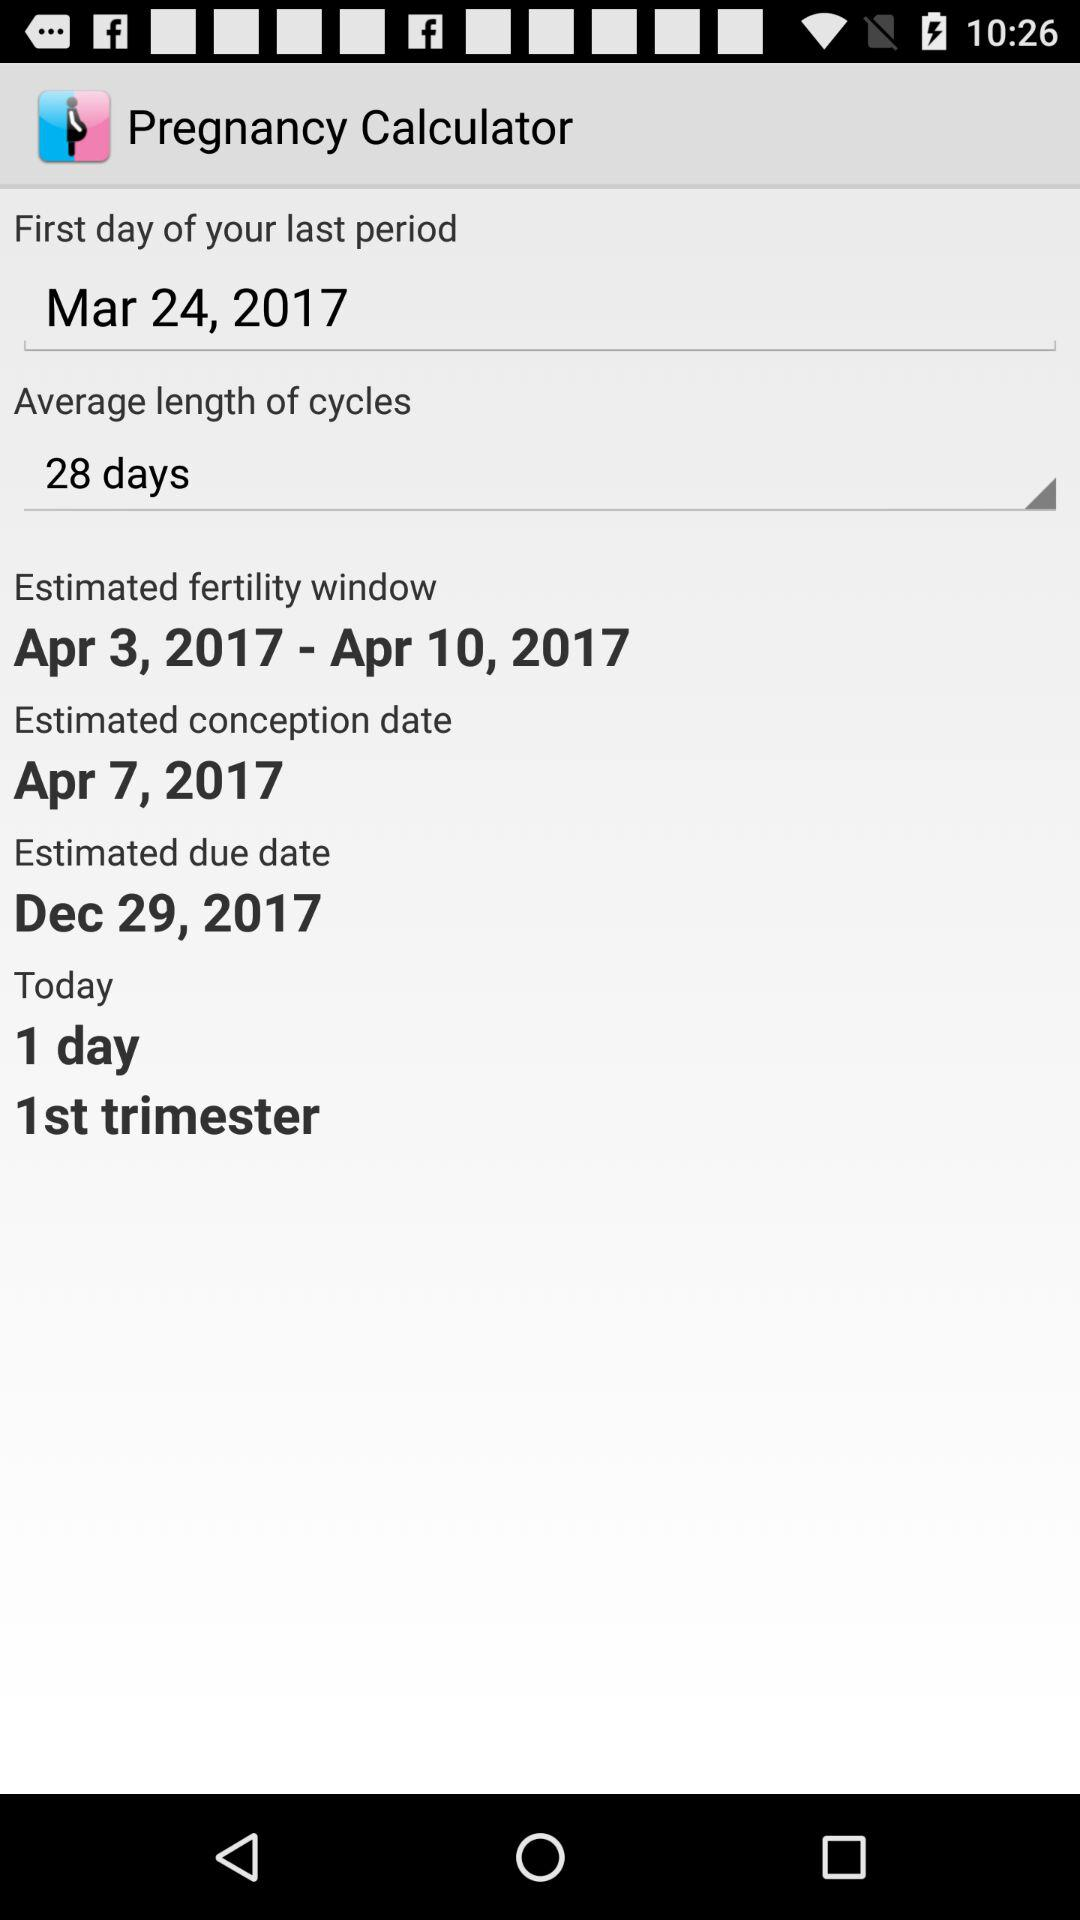What is the duration of the estimated fertility window? The duration of the estimated fertility window is from April 3, 2017 to April 10, 2017. 